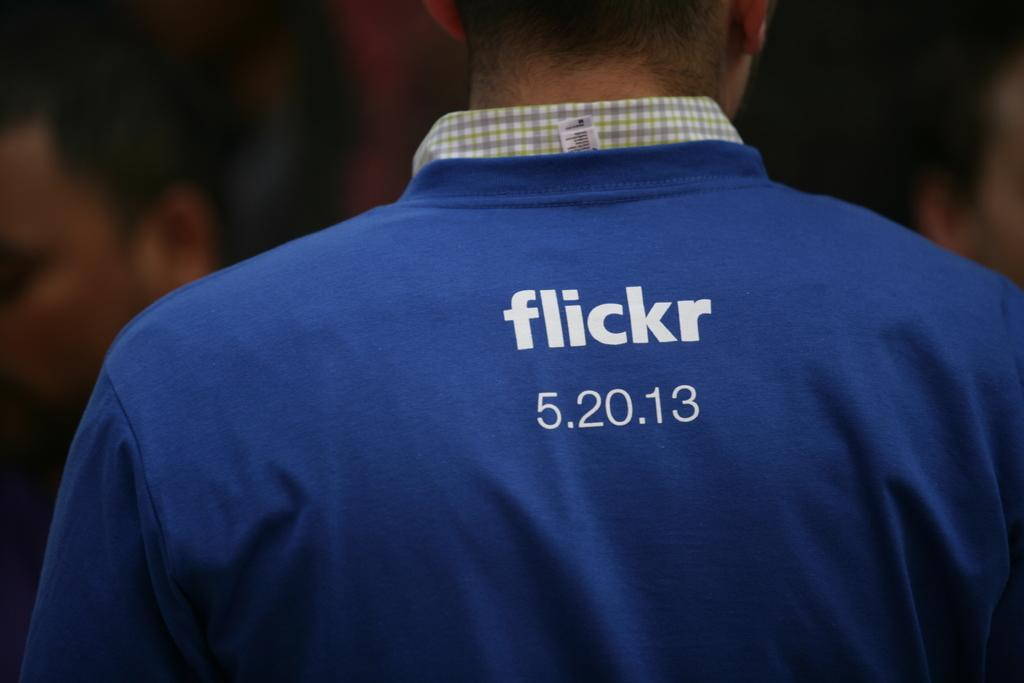<image>
Summarize the visual content of the image. A standing up person wearing a blue Flickr shirt. 